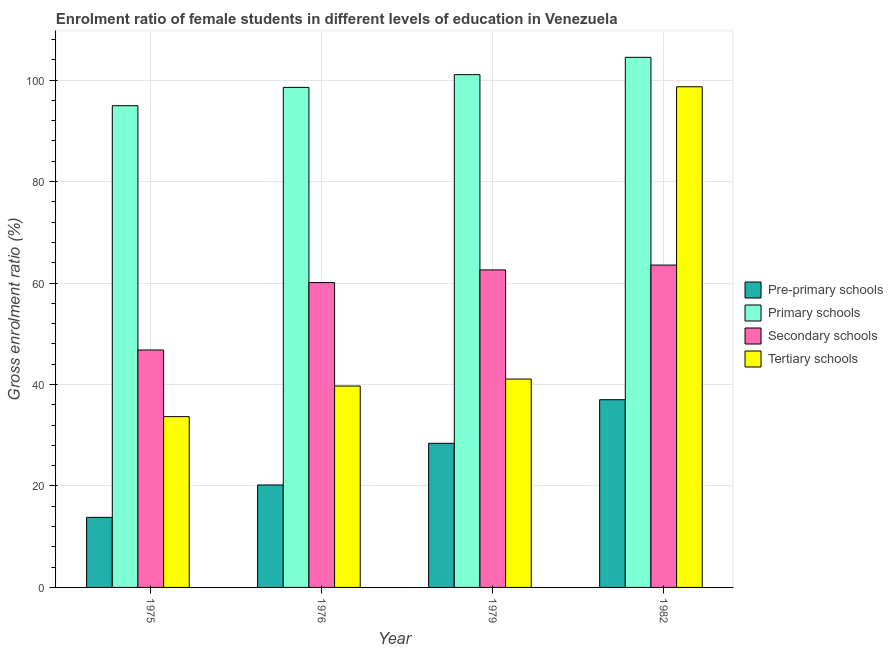How many groups of bars are there?
Provide a succinct answer. 4. Are the number of bars per tick equal to the number of legend labels?
Keep it short and to the point. Yes. Are the number of bars on each tick of the X-axis equal?
Ensure brevity in your answer.  Yes. How many bars are there on the 4th tick from the left?
Ensure brevity in your answer.  4. In how many cases, is the number of bars for a given year not equal to the number of legend labels?
Offer a terse response. 0. What is the gross enrolment ratio(male) in primary schools in 1979?
Give a very brief answer. 101.06. Across all years, what is the maximum gross enrolment ratio(male) in tertiary schools?
Ensure brevity in your answer.  98.68. Across all years, what is the minimum gross enrolment ratio(male) in secondary schools?
Provide a short and direct response. 46.79. In which year was the gross enrolment ratio(male) in pre-primary schools maximum?
Provide a short and direct response. 1982. In which year was the gross enrolment ratio(male) in primary schools minimum?
Offer a terse response. 1975. What is the total gross enrolment ratio(male) in secondary schools in the graph?
Offer a very short reply. 233. What is the difference between the gross enrolment ratio(male) in pre-primary schools in 1975 and that in 1982?
Offer a terse response. -23.19. What is the difference between the gross enrolment ratio(male) in primary schools in 1979 and the gross enrolment ratio(male) in tertiary schools in 1975?
Your response must be concise. 6.12. What is the average gross enrolment ratio(male) in tertiary schools per year?
Ensure brevity in your answer.  53.28. In how many years, is the gross enrolment ratio(male) in primary schools greater than 28 %?
Ensure brevity in your answer.  4. What is the ratio of the gross enrolment ratio(male) in secondary schools in 1976 to that in 1982?
Your response must be concise. 0.95. What is the difference between the highest and the second highest gross enrolment ratio(male) in tertiary schools?
Provide a short and direct response. 57.6. What is the difference between the highest and the lowest gross enrolment ratio(male) in tertiary schools?
Keep it short and to the point. 65.02. What does the 2nd bar from the left in 1976 represents?
Give a very brief answer. Primary schools. What does the 3rd bar from the right in 1976 represents?
Offer a terse response. Primary schools. How many bars are there?
Make the answer very short. 16. Are all the bars in the graph horizontal?
Offer a terse response. No. How many years are there in the graph?
Give a very brief answer. 4. What is the difference between two consecutive major ticks on the Y-axis?
Your answer should be compact. 20. Are the values on the major ticks of Y-axis written in scientific E-notation?
Offer a terse response. No. Does the graph contain grids?
Your response must be concise. Yes. Where does the legend appear in the graph?
Your response must be concise. Center right. How many legend labels are there?
Your answer should be compact. 4. What is the title of the graph?
Your answer should be compact. Enrolment ratio of female students in different levels of education in Venezuela. What is the label or title of the X-axis?
Ensure brevity in your answer.  Year. What is the label or title of the Y-axis?
Your response must be concise. Gross enrolment ratio (%). What is the Gross enrolment ratio (%) of Pre-primary schools in 1975?
Provide a short and direct response. 13.81. What is the Gross enrolment ratio (%) of Primary schools in 1975?
Provide a short and direct response. 94.94. What is the Gross enrolment ratio (%) of Secondary schools in 1975?
Your answer should be compact. 46.79. What is the Gross enrolment ratio (%) of Tertiary schools in 1975?
Keep it short and to the point. 33.66. What is the Gross enrolment ratio (%) in Pre-primary schools in 1976?
Keep it short and to the point. 20.2. What is the Gross enrolment ratio (%) of Primary schools in 1976?
Keep it short and to the point. 98.56. What is the Gross enrolment ratio (%) of Secondary schools in 1976?
Offer a terse response. 60.09. What is the Gross enrolment ratio (%) of Tertiary schools in 1976?
Offer a terse response. 39.69. What is the Gross enrolment ratio (%) of Pre-primary schools in 1979?
Give a very brief answer. 28.41. What is the Gross enrolment ratio (%) in Primary schools in 1979?
Your answer should be very brief. 101.06. What is the Gross enrolment ratio (%) in Secondary schools in 1979?
Keep it short and to the point. 62.58. What is the Gross enrolment ratio (%) in Tertiary schools in 1979?
Provide a short and direct response. 41.07. What is the Gross enrolment ratio (%) of Pre-primary schools in 1982?
Provide a short and direct response. 37. What is the Gross enrolment ratio (%) in Primary schools in 1982?
Provide a short and direct response. 104.48. What is the Gross enrolment ratio (%) in Secondary schools in 1982?
Offer a terse response. 63.53. What is the Gross enrolment ratio (%) in Tertiary schools in 1982?
Ensure brevity in your answer.  98.68. Across all years, what is the maximum Gross enrolment ratio (%) of Pre-primary schools?
Offer a terse response. 37. Across all years, what is the maximum Gross enrolment ratio (%) of Primary schools?
Offer a very short reply. 104.48. Across all years, what is the maximum Gross enrolment ratio (%) of Secondary schools?
Offer a terse response. 63.53. Across all years, what is the maximum Gross enrolment ratio (%) in Tertiary schools?
Offer a very short reply. 98.68. Across all years, what is the minimum Gross enrolment ratio (%) in Pre-primary schools?
Offer a terse response. 13.81. Across all years, what is the minimum Gross enrolment ratio (%) of Primary schools?
Offer a terse response. 94.94. Across all years, what is the minimum Gross enrolment ratio (%) of Secondary schools?
Offer a terse response. 46.79. Across all years, what is the minimum Gross enrolment ratio (%) of Tertiary schools?
Provide a succinct answer. 33.66. What is the total Gross enrolment ratio (%) of Pre-primary schools in the graph?
Your response must be concise. 99.41. What is the total Gross enrolment ratio (%) in Primary schools in the graph?
Offer a very short reply. 399.05. What is the total Gross enrolment ratio (%) of Secondary schools in the graph?
Your response must be concise. 233. What is the total Gross enrolment ratio (%) in Tertiary schools in the graph?
Offer a terse response. 213.11. What is the difference between the Gross enrolment ratio (%) of Pre-primary schools in 1975 and that in 1976?
Keep it short and to the point. -6.39. What is the difference between the Gross enrolment ratio (%) of Primary schools in 1975 and that in 1976?
Provide a succinct answer. -3.61. What is the difference between the Gross enrolment ratio (%) in Secondary schools in 1975 and that in 1976?
Ensure brevity in your answer.  -13.29. What is the difference between the Gross enrolment ratio (%) in Tertiary schools in 1975 and that in 1976?
Ensure brevity in your answer.  -6.03. What is the difference between the Gross enrolment ratio (%) of Pre-primary schools in 1975 and that in 1979?
Give a very brief answer. -14.6. What is the difference between the Gross enrolment ratio (%) of Primary schools in 1975 and that in 1979?
Keep it short and to the point. -6.12. What is the difference between the Gross enrolment ratio (%) in Secondary schools in 1975 and that in 1979?
Your response must be concise. -15.79. What is the difference between the Gross enrolment ratio (%) of Tertiary schools in 1975 and that in 1979?
Your response must be concise. -7.41. What is the difference between the Gross enrolment ratio (%) of Pre-primary schools in 1975 and that in 1982?
Your answer should be compact. -23.19. What is the difference between the Gross enrolment ratio (%) of Primary schools in 1975 and that in 1982?
Keep it short and to the point. -9.54. What is the difference between the Gross enrolment ratio (%) of Secondary schools in 1975 and that in 1982?
Keep it short and to the point. -16.74. What is the difference between the Gross enrolment ratio (%) of Tertiary schools in 1975 and that in 1982?
Make the answer very short. -65.02. What is the difference between the Gross enrolment ratio (%) of Pre-primary schools in 1976 and that in 1979?
Your answer should be very brief. -8.21. What is the difference between the Gross enrolment ratio (%) in Primary schools in 1976 and that in 1979?
Provide a short and direct response. -2.51. What is the difference between the Gross enrolment ratio (%) of Secondary schools in 1976 and that in 1979?
Provide a succinct answer. -2.5. What is the difference between the Gross enrolment ratio (%) in Tertiary schools in 1976 and that in 1979?
Your response must be concise. -1.38. What is the difference between the Gross enrolment ratio (%) in Pre-primary schools in 1976 and that in 1982?
Make the answer very short. -16.8. What is the difference between the Gross enrolment ratio (%) in Primary schools in 1976 and that in 1982?
Your answer should be compact. -5.92. What is the difference between the Gross enrolment ratio (%) in Secondary schools in 1976 and that in 1982?
Offer a very short reply. -3.45. What is the difference between the Gross enrolment ratio (%) in Tertiary schools in 1976 and that in 1982?
Make the answer very short. -58.98. What is the difference between the Gross enrolment ratio (%) in Pre-primary schools in 1979 and that in 1982?
Keep it short and to the point. -8.59. What is the difference between the Gross enrolment ratio (%) in Primary schools in 1979 and that in 1982?
Offer a very short reply. -3.42. What is the difference between the Gross enrolment ratio (%) in Secondary schools in 1979 and that in 1982?
Make the answer very short. -0.95. What is the difference between the Gross enrolment ratio (%) in Tertiary schools in 1979 and that in 1982?
Keep it short and to the point. -57.6. What is the difference between the Gross enrolment ratio (%) of Pre-primary schools in 1975 and the Gross enrolment ratio (%) of Primary schools in 1976?
Ensure brevity in your answer.  -84.75. What is the difference between the Gross enrolment ratio (%) in Pre-primary schools in 1975 and the Gross enrolment ratio (%) in Secondary schools in 1976?
Offer a terse response. -46.28. What is the difference between the Gross enrolment ratio (%) in Pre-primary schools in 1975 and the Gross enrolment ratio (%) in Tertiary schools in 1976?
Offer a very short reply. -25.89. What is the difference between the Gross enrolment ratio (%) in Primary schools in 1975 and the Gross enrolment ratio (%) in Secondary schools in 1976?
Ensure brevity in your answer.  34.86. What is the difference between the Gross enrolment ratio (%) in Primary schools in 1975 and the Gross enrolment ratio (%) in Tertiary schools in 1976?
Give a very brief answer. 55.25. What is the difference between the Gross enrolment ratio (%) of Secondary schools in 1975 and the Gross enrolment ratio (%) of Tertiary schools in 1976?
Provide a short and direct response. 7.1. What is the difference between the Gross enrolment ratio (%) of Pre-primary schools in 1975 and the Gross enrolment ratio (%) of Primary schools in 1979?
Give a very brief answer. -87.25. What is the difference between the Gross enrolment ratio (%) in Pre-primary schools in 1975 and the Gross enrolment ratio (%) in Secondary schools in 1979?
Make the answer very short. -48.77. What is the difference between the Gross enrolment ratio (%) of Pre-primary schools in 1975 and the Gross enrolment ratio (%) of Tertiary schools in 1979?
Give a very brief answer. -27.26. What is the difference between the Gross enrolment ratio (%) of Primary schools in 1975 and the Gross enrolment ratio (%) of Secondary schools in 1979?
Your answer should be very brief. 32.36. What is the difference between the Gross enrolment ratio (%) of Primary schools in 1975 and the Gross enrolment ratio (%) of Tertiary schools in 1979?
Your response must be concise. 53.87. What is the difference between the Gross enrolment ratio (%) in Secondary schools in 1975 and the Gross enrolment ratio (%) in Tertiary schools in 1979?
Provide a succinct answer. 5.72. What is the difference between the Gross enrolment ratio (%) in Pre-primary schools in 1975 and the Gross enrolment ratio (%) in Primary schools in 1982?
Give a very brief answer. -90.67. What is the difference between the Gross enrolment ratio (%) in Pre-primary schools in 1975 and the Gross enrolment ratio (%) in Secondary schools in 1982?
Your response must be concise. -49.73. What is the difference between the Gross enrolment ratio (%) in Pre-primary schools in 1975 and the Gross enrolment ratio (%) in Tertiary schools in 1982?
Your answer should be compact. -84.87. What is the difference between the Gross enrolment ratio (%) in Primary schools in 1975 and the Gross enrolment ratio (%) in Secondary schools in 1982?
Provide a short and direct response. 31.41. What is the difference between the Gross enrolment ratio (%) in Primary schools in 1975 and the Gross enrolment ratio (%) in Tertiary schools in 1982?
Ensure brevity in your answer.  -3.73. What is the difference between the Gross enrolment ratio (%) in Secondary schools in 1975 and the Gross enrolment ratio (%) in Tertiary schools in 1982?
Your answer should be compact. -51.88. What is the difference between the Gross enrolment ratio (%) of Pre-primary schools in 1976 and the Gross enrolment ratio (%) of Primary schools in 1979?
Ensure brevity in your answer.  -80.87. What is the difference between the Gross enrolment ratio (%) in Pre-primary schools in 1976 and the Gross enrolment ratio (%) in Secondary schools in 1979?
Keep it short and to the point. -42.39. What is the difference between the Gross enrolment ratio (%) of Pre-primary schools in 1976 and the Gross enrolment ratio (%) of Tertiary schools in 1979?
Ensure brevity in your answer.  -20.88. What is the difference between the Gross enrolment ratio (%) of Primary schools in 1976 and the Gross enrolment ratio (%) of Secondary schools in 1979?
Your answer should be very brief. 35.98. What is the difference between the Gross enrolment ratio (%) of Primary schools in 1976 and the Gross enrolment ratio (%) of Tertiary schools in 1979?
Keep it short and to the point. 57.48. What is the difference between the Gross enrolment ratio (%) in Secondary schools in 1976 and the Gross enrolment ratio (%) in Tertiary schools in 1979?
Your response must be concise. 19.01. What is the difference between the Gross enrolment ratio (%) of Pre-primary schools in 1976 and the Gross enrolment ratio (%) of Primary schools in 1982?
Offer a very short reply. -84.28. What is the difference between the Gross enrolment ratio (%) of Pre-primary schools in 1976 and the Gross enrolment ratio (%) of Secondary schools in 1982?
Your answer should be compact. -43.34. What is the difference between the Gross enrolment ratio (%) in Pre-primary schools in 1976 and the Gross enrolment ratio (%) in Tertiary schools in 1982?
Provide a succinct answer. -78.48. What is the difference between the Gross enrolment ratio (%) in Primary schools in 1976 and the Gross enrolment ratio (%) in Secondary schools in 1982?
Offer a very short reply. 35.02. What is the difference between the Gross enrolment ratio (%) in Primary schools in 1976 and the Gross enrolment ratio (%) in Tertiary schools in 1982?
Keep it short and to the point. -0.12. What is the difference between the Gross enrolment ratio (%) of Secondary schools in 1976 and the Gross enrolment ratio (%) of Tertiary schools in 1982?
Provide a succinct answer. -38.59. What is the difference between the Gross enrolment ratio (%) of Pre-primary schools in 1979 and the Gross enrolment ratio (%) of Primary schools in 1982?
Your response must be concise. -76.07. What is the difference between the Gross enrolment ratio (%) of Pre-primary schools in 1979 and the Gross enrolment ratio (%) of Secondary schools in 1982?
Provide a succinct answer. -35.13. What is the difference between the Gross enrolment ratio (%) of Pre-primary schools in 1979 and the Gross enrolment ratio (%) of Tertiary schools in 1982?
Your response must be concise. -70.27. What is the difference between the Gross enrolment ratio (%) of Primary schools in 1979 and the Gross enrolment ratio (%) of Secondary schools in 1982?
Make the answer very short. 37.53. What is the difference between the Gross enrolment ratio (%) in Primary schools in 1979 and the Gross enrolment ratio (%) in Tertiary schools in 1982?
Keep it short and to the point. 2.39. What is the difference between the Gross enrolment ratio (%) of Secondary schools in 1979 and the Gross enrolment ratio (%) of Tertiary schools in 1982?
Make the answer very short. -36.1. What is the average Gross enrolment ratio (%) in Pre-primary schools per year?
Keep it short and to the point. 24.85. What is the average Gross enrolment ratio (%) of Primary schools per year?
Offer a very short reply. 99.76. What is the average Gross enrolment ratio (%) of Secondary schools per year?
Make the answer very short. 58.25. What is the average Gross enrolment ratio (%) in Tertiary schools per year?
Give a very brief answer. 53.28. In the year 1975, what is the difference between the Gross enrolment ratio (%) of Pre-primary schools and Gross enrolment ratio (%) of Primary schools?
Provide a succinct answer. -81.14. In the year 1975, what is the difference between the Gross enrolment ratio (%) of Pre-primary schools and Gross enrolment ratio (%) of Secondary schools?
Provide a short and direct response. -32.99. In the year 1975, what is the difference between the Gross enrolment ratio (%) in Pre-primary schools and Gross enrolment ratio (%) in Tertiary schools?
Ensure brevity in your answer.  -19.85. In the year 1975, what is the difference between the Gross enrolment ratio (%) in Primary schools and Gross enrolment ratio (%) in Secondary schools?
Give a very brief answer. 48.15. In the year 1975, what is the difference between the Gross enrolment ratio (%) of Primary schools and Gross enrolment ratio (%) of Tertiary schools?
Keep it short and to the point. 61.28. In the year 1975, what is the difference between the Gross enrolment ratio (%) of Secondary schools and Gross enrolment ratio (%) of Tertiary schools?
Give a very brief answer. 13.13. In the year 1976, what is the difference between the Gross enrolment ratio (%) of Pre-primary schools and Gross enrolment ratio (%) of Primary schools?
Provide a succinct answer. -78.36. In the year 1976, what is the difference between the Gross enrolment ratio (%) of Pre-primary schools and Gross enrolment ratio (%) of Secondary schools?
Keep it short and to the point. -39.89. In the year 1976, what is the difference between the Gross enrolment ratio (%) of Pre-primary schools and Gross enrolment ratio (%) of Tertiary schools?
Give a very brief answer. -19.5. In the year 1976, what is the difference between the Gross enrolment ratio (%) of Primary schools and Gross enrolment ratio (%) of Secondary schools?
Your answer should be very brief. 38.47. In the year 1976, what is the difference between the Gross enrolment ratio (%) of Primary schools and Gross enrolment ratio (%) of Tertiary schools?
Offer a terse response. 58.86. In the year 1976, what is the difference between the Gross enrolment ratio (%) in Secondary schools and Gross enrolment ratio (%) in Tertiary schools?
Keep it short and to the point. 20.39. In the year 1979, what is the difference between the Gross enrolment ratio (%) in Pre-primary schools and Gross enrolment ratio (%) in Primary schools?
Offer a terse response. -72.66. In the year 1979, what is the difference between the Gross enrolment ratio (%) in Pre-primary schools and Gross enrolment ratio (%) in Secondary schools?
Provide a succinct answer. -34.17. In the year 1979, what is the difference between the Gross enrolment ratio (%) in Pre-primary schools and Gross enrolment ratio (%) in Tertiary schools?
Make the answer very short. -12.67. In the year 1979, what is the difference between the Gross enrolment ratio (%) in Primary schools and Gross enrolment ratio (%) in Secondary schools?
Make the answer very short. 38.48. In the year 1979, what is the difference between the Gross enrolment ratio (%) of Primary schools and Gross enrolment ratio (%) of Tertiary schools?
Keep it short and to the point. 59.99. In the year 1979, what is the difference between the Gross enrolment ratio (%) of Secondary schools and Gross enrolment ratio (%) of Tertiary schools?
Make the answer very short. 21.51. In the year 1982, what is the difference between the Gross enrolment ratio (%) of Pre-primary schools and Gross enrolment ratio (%) of Primary schools?
Make the answer very short. -67.48. In the year 1982, what is the difference between the Gross enrolment ratio (%) of Pre-primary schools and Gross enrolment ratio (%) of Secondary schools?
Offer a terse response. -26.54. In the year 1982, what is the difference between the Gross enrolment ratio (%) in Pre-primary schools and Gross enrolment ratio (%) in Tertiary schools?
Offer a terse response. -61.68. In the year 1982, what is the difference between the Gross enrolment ratio (%) in Primary schools and Gross enrolment ratio (%) in Secondary schools?
Provide a succinct answer. 40.95. In the year 1982, what is the difference between the Gross enrolment ratio (%) in Primary schools and Gross enrolment ratio (%) in Tertiary schools?
Ensure brevity in your answer.  5.8. In the year 1982, what is the difference between the Gross enrolment ratio (%) in Secondary schools and Gross enrolment ratio (%) in Tertiary schools?
Offer a terse response. -35.14. What is the ratio of the Gross enrolment ratio (%) of Pre-primary schools in 1975 to that in 1976?
Keep it short and to the point. 0.68. What is the ratio of the Gross enrolment ratio (%) of Primary schools in 1975 to that in 1976?
Your answer should be compact. 0.96. What is the ratio of the Gross enrolment ratio (%) of Secondary schools in 1975 to that in 1976?
Offer a very short reply. 0.78. What is the ratio of the Gross enrolment ratio (%) of Tertiary schools in 1975 to that in 1976?
Give a very brief answer. 0.85. What is the ratio of the Gross enrolment ratio (%) in Pre-primary schools in 1975 to that in 1979?
Provide a succinct answer. 0.49. What is the ratio of the Gross enrolment ratio (%) in Primary schools in 1975 to that in 1979?
Your answer should be very brief. 0.94. What is the ratio of the Gross enrolment ratio (%) of Secondary schools in 1975 to that in 1979?
Your response must be concise. 0.75. What is the ratio of the Gross enrolment ratio (%) of Tertiary schools in 1975 to that in 1979?
Your answer should be compact. 0.82. What is the ratio of the Gross enrolment ratio (%) of Pre-primary schools in 1975 to that in 1982?
Your response must be concise. 0.37. What is the ratio of the Gross enrolment ratio (%) of Primary schools in 1975 to that in 1982?
Offer a terse response. 0.91. What is the ratio of the Gross enrolment ratio (%) in Secondary schools in 1975 to that in 1982?
Give a very brief answer. 0.74. What is the ratio of the Gross enrolment ratio (%) of Tertiary schools in 1975 to that in 1982?
Keep it short and to the point. 0.34. What is the ratio of the Gross enrolment ratio (%) of Pre-primary schools in 1976 to that in 1979?
Provide a short and direct response. 0.71. What is the ratio of the Gross enrolment ratio (%) in Primary schools in 1976 to that in 1979?
Your response must be concise. 0.98. What is the ratio of the Gross enrolment ratio (%) in Secondary schools in 1976 to that in 1979?
Your answer should be very brief. 0.96. What is the ratio of the Gross enrolment ratio (%) in Tertiary schools in 1976 to that in 1979?
Your answer should be very brief. 0.97. What is the ratio of the Gross enrolment ratio (%) in Pre-primary schools in 1976 to that in 1982?
Offer a terse response. 0.55. What is the ratio of the Gross enrolment ratio (%) in Primary schools in 1976 to that in 1982?
Offer a very short reply. 0.94. What is the ratio of the Gross enrolment ratio (%) in Secondary schools in 1976 to that in 1982?
Make the answer very short. 0.95. What is the ratio of the Gross enrolment ratio (%) of Tertiary schools in 1976 to that in 1982?
Provide a short and direct response. 0.4. What is the ratio of the Gross enrolment ratio (%) of Pre-primary schools in 1979 to that in 1982?
Provide a short and direct response. 0.77. What is the ratio of the Gross enrolment ratio (%) of Primary schools in 1979 to that in 1982?
Offer a very short reply. 0.97. What is the ratio of the Gross enrolment ratio (%) in Secondary schools in 1979 to that in 1982?
Give a very brief answer. 0.98. What is the ratio of the Gross enrolment ratio (%) of Tertiary schools in 1979 to that in 1982?
Your answer should be very brief. 0.42. What is the difference between the highest and the second highest Gross enrolment ratio (%) in Pre-primary schools?
Offer a terse response. 8.59. What is the difference between the highest and the second highest Gross enrolment ratio (%) of Primary schools?
Keep it short and to the point. 3.42. What is the difference between the highest and the second highest Gross enrolment ratio (%) of Secondary schools?
Your answer should be very brief. 0.95. What is the difference between the highest and the second highest Gross enrolment ratio (%) in Tertiary schools?
Provide a succinct answer. 57.6. What is the difference between the highest and the lowest Gross enrolment ratio (%) in Pre-primary schools?
Your answer should be compact. 23.19. What is the difference between the highest and the lowest Gross enrolment ratio (%) of Primary schools?
Offer a terse response. 9.54. What is the difference between the highest and the lowest Gross enrolment ratio (%) in Secondary schools?
Ensure brevity in your answer.  16.74. What is the difference between the highest and the lowest Gross enrolment ratio (%) of Tertiary schools?
Provide a short and direct response. 65.02. 